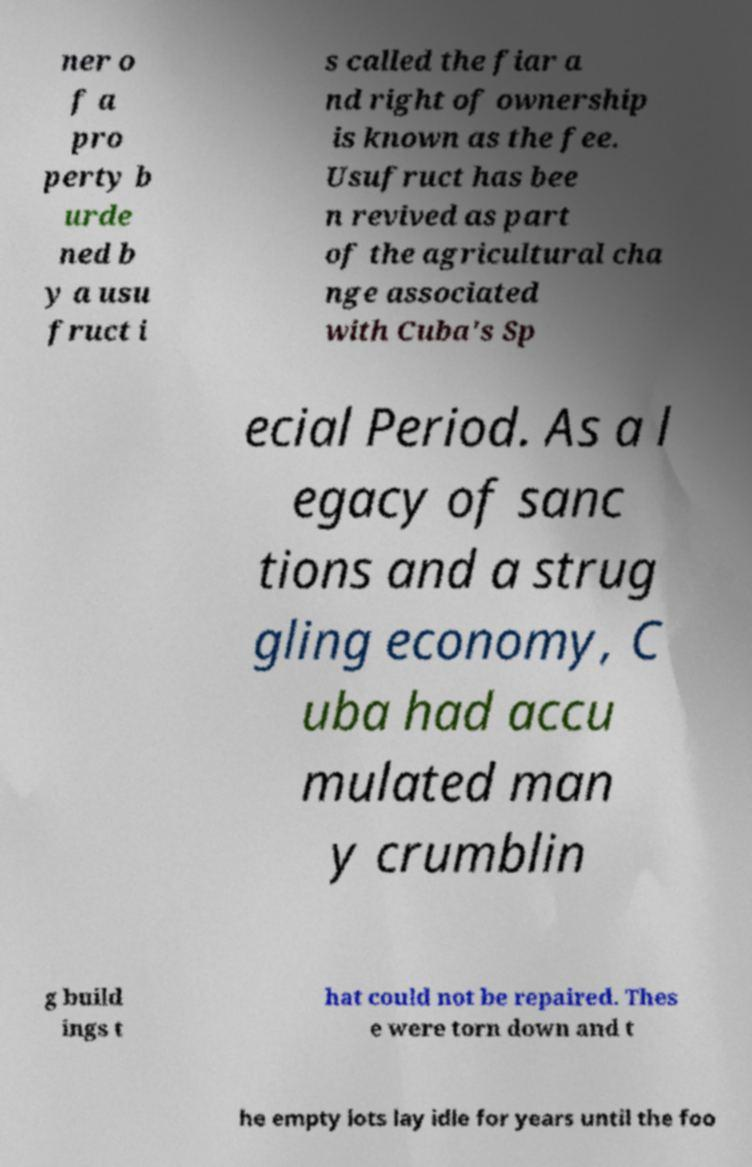Please identify and transcribe the text found in this image. ner o f a pro perty b urde ned b y a usu fruct i s called the fiar a nd right of ownership is known as the fee. Usufruct has bee n revived as part of the agricultural cha nge associated with Cuba's Sp ecial Period. As a l egacy of sanc tions and a strug gling economy, C uba had accu mulated man y crumblin g build ings t hat could not be repaired. Thes e were torn down and t he empty lots lay idle for years until the foo 